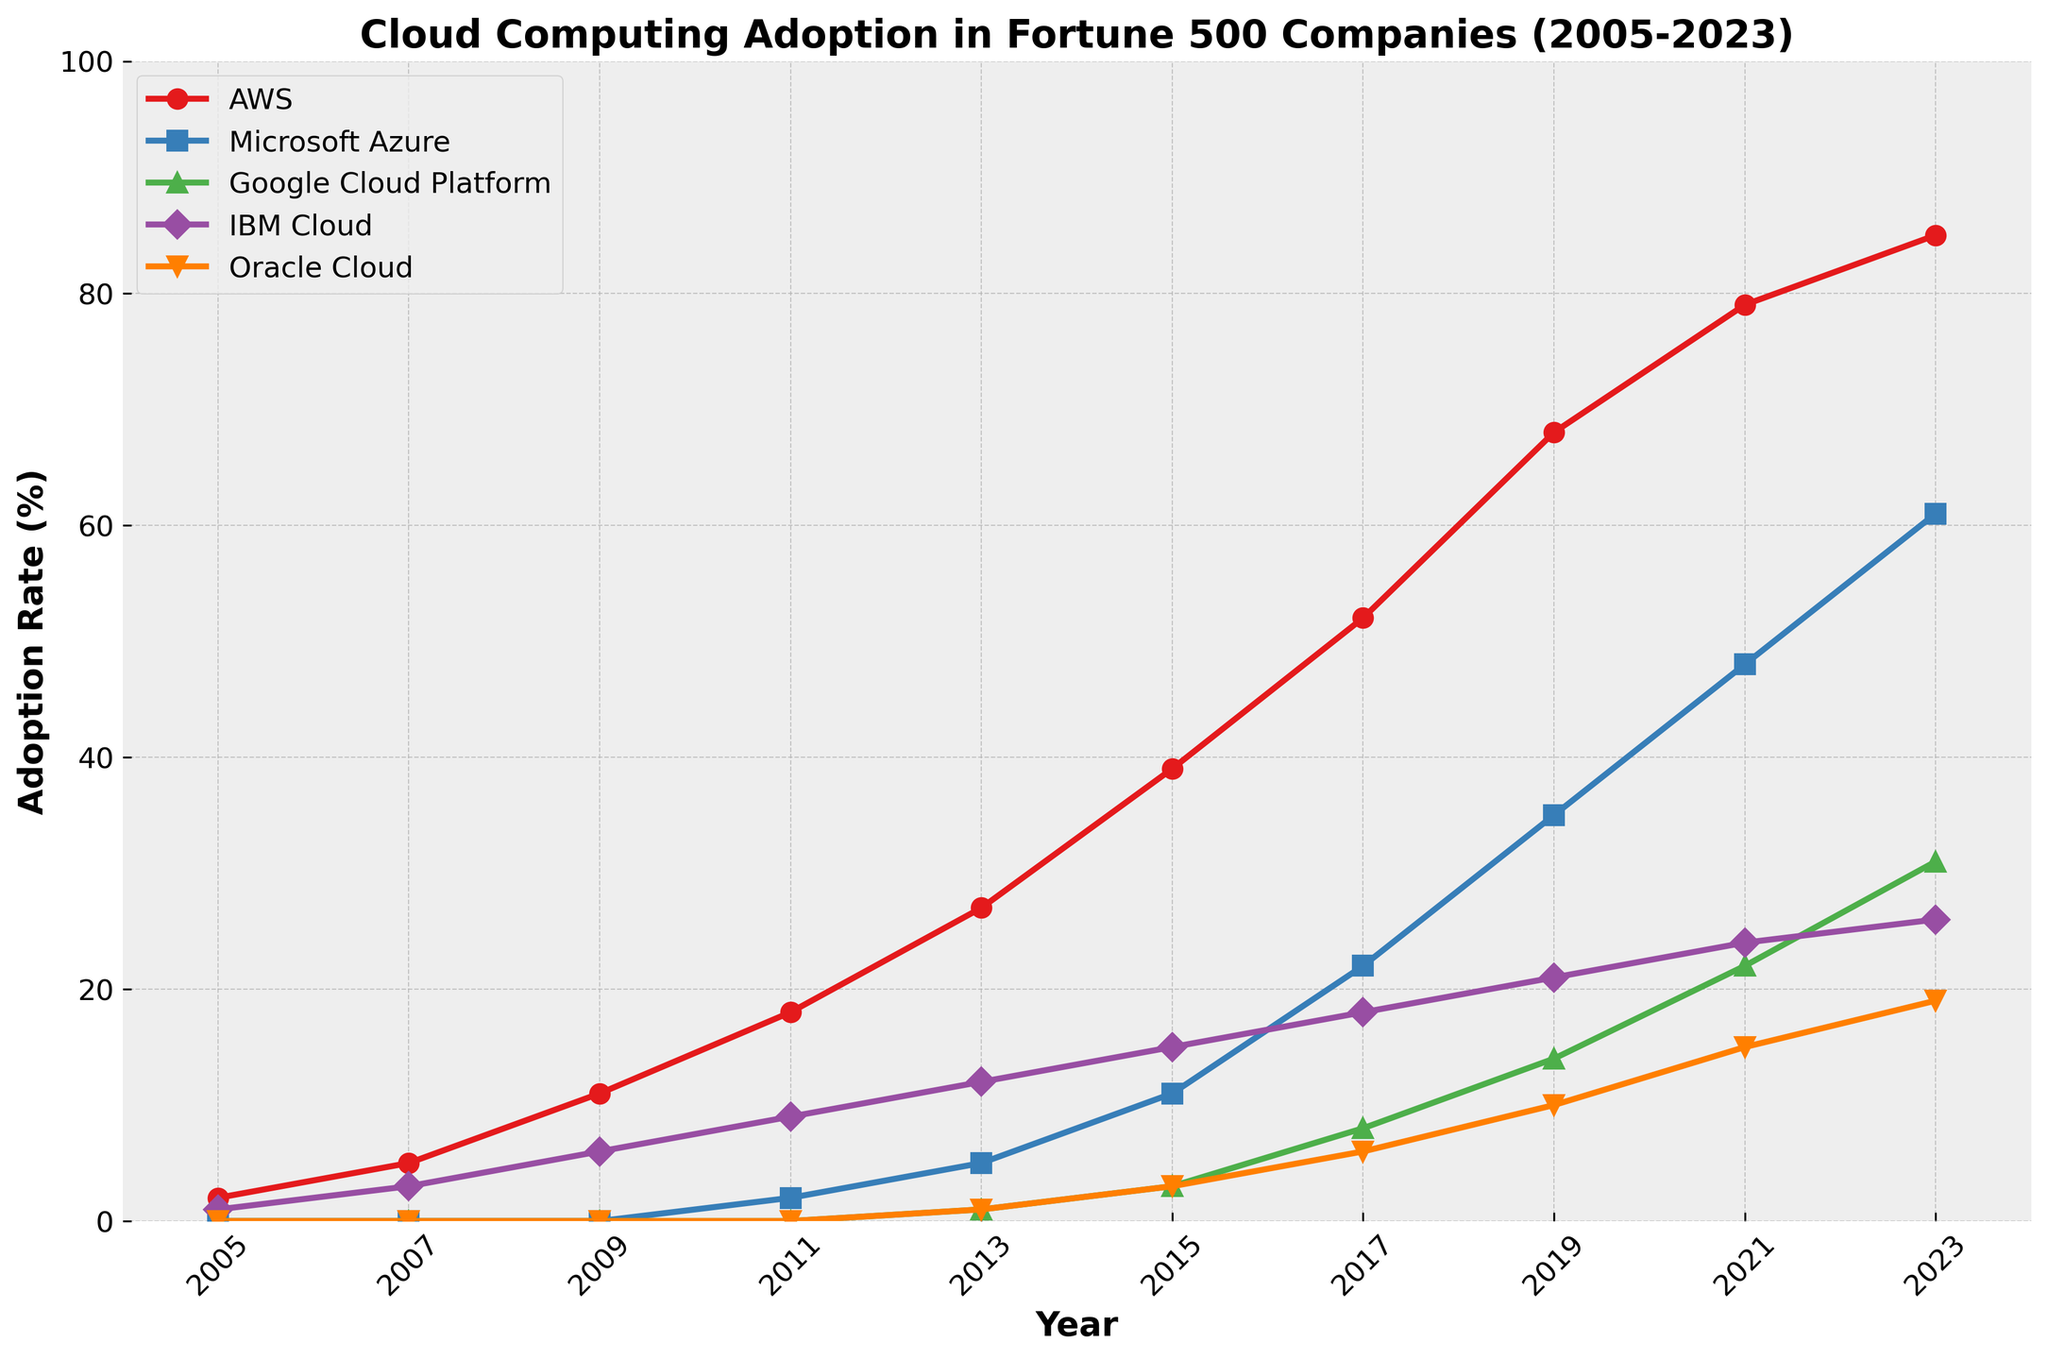Which cloud provider had the highest adoption rate in 2023? The graph shows the adoption rates of different cloud providers across the years. In 2023, AWS reaches the highest point on the y-axis among all the providers.
Answer: AWS What was the adoption rate of Google Cloud Platform in 2015? Locate the data point for Google Cloud Platform at the year 2015. The point's y-value represents the adoption rate, which is 3%.
Answer: 3 Which company showed no adoption before 2011 and saw growth afterwards? Looking at the lines, Oracle Cloud showed zero adoption (stayed on the x-axis) until 2011 and saw growth starting afterwards.
Answer: Oracle Cloud By how much did AWS's adoption rate increase from 2019 to 2023? Find AWS's adoption rates for the years 2019 and 2023. Subtract the 2019 value (68) from the 2023 value (85).
Answer: 17 Which year saw IBM Cloud's adoption rate reach 15%? Look for the data points where IBM Cloud's adoption rate hits 15%, which occurs between 2013 and 2015. Therefore, in 2015, IBM Cloud's adoption rate was 15%.
Answer: 2015 Compare the adoption rates of Microsoft Azure and Google Cloud Platform in 2023. Which one is higher and by how much? Check the y-values for Microsoft Azure and Google Cloud Platform in 2023. Azure has an adoption rate of 61%, and Google has 31%. Subtract the latter from the former (61 - 31).
Answer: Microsoft Azure by 30 Identify the provider with the second highest adoption rate in 2021. In 2021, locate the second highest y-value. Microsoft Azure, with an adoption rate of 48%, is the second highest after AWS.
Answer: Microsoft Azure Calculate the average adoption rate of IBM Cloud over all the years shown. Sum up IBM Cloud's adoption rates from all years and divide by the number of years (1 + 3 + 6 + 9 + 12 + 15 + 18 + 21 + 24 + 26)/10 = 13.5.
Answer: 13.5 What trend is observed for AWS's adoption rate from 2005 to 2023? Trace the AWS line across the years from left to right. It shows a consistently increasing trend, indicating a growing adoption rate over time.
Answer: Increasing 